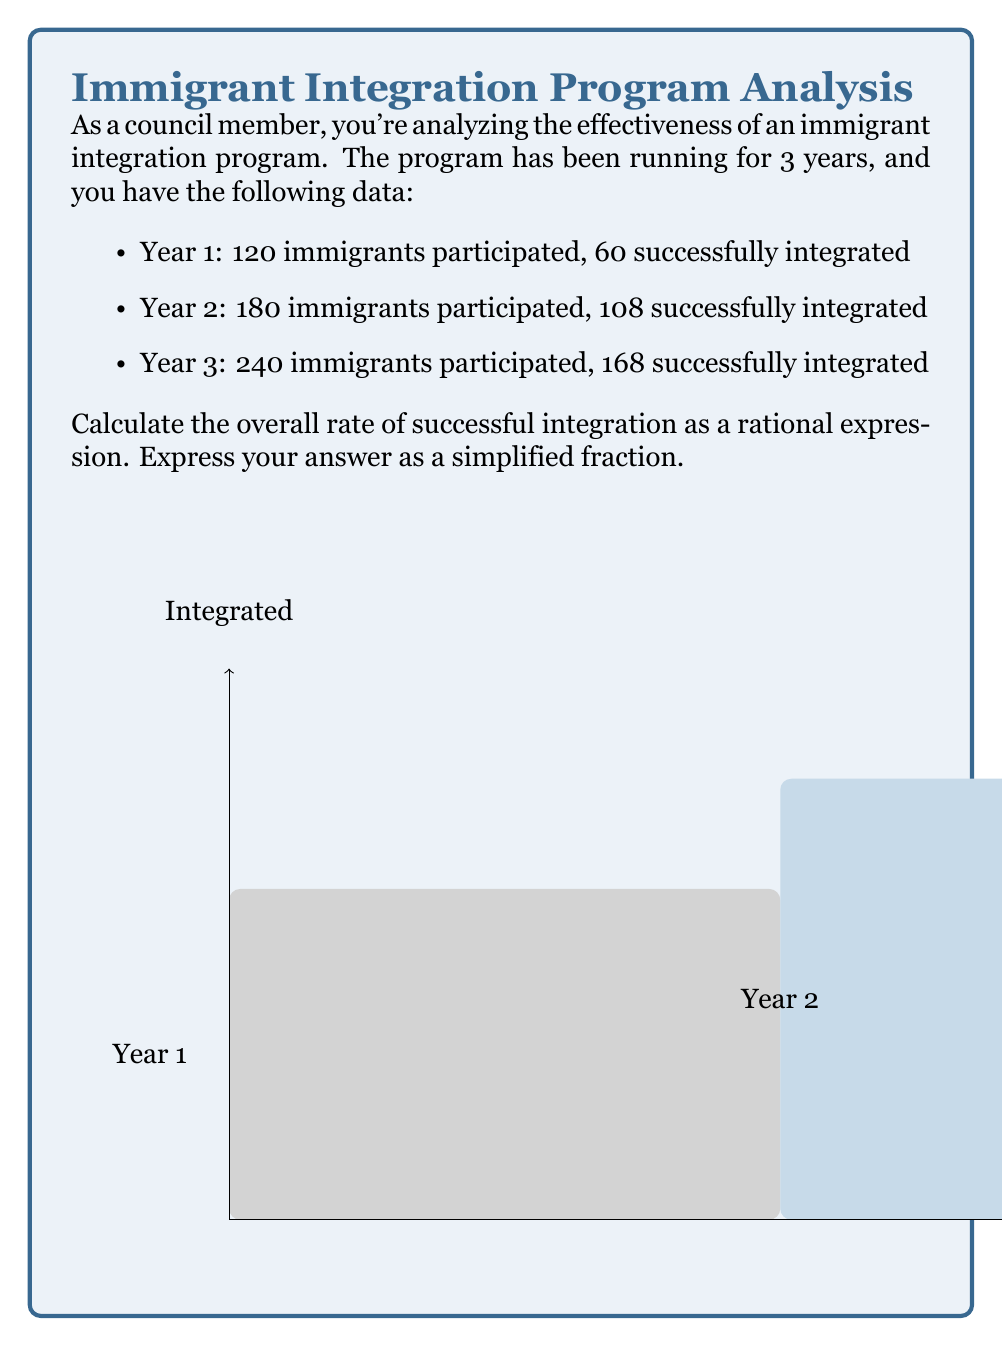Could you help me with this problem? Let's approach this step-by-step:

1) First, we need to find the total number of participants and the total number of successfully integrated immigrants over the three years.

   Total participants = 120 + 180 + 240 = 540
   Total integrated = 60 + 108 + 168 = 336

2) The rate of successful integration can be expressed as a ratio:

   $\text{Rate} = \frac{\text{Total integrated}}{\text{Total participants}}$

3) Substituting our values:

   $\text{Rate} = \frac{336}{540}$

4) To simplify this fraction, we need to find the greatest common divisor (GCD) of 336 and 540.
   
   Factors of 336: 1, 2, 3, 4, 6, 7, 8, 12, 14, 16, 21, 24, 28, 42, 48, 56, 84, 112, 168, 336
   Factors of 540: 1, 2, 3, 4, 5, 6, 9, 10, 12, 15, 18, 20, 27, 30, 36, 45, 54, 60, 90, 108, 135, 180, 270, 540

   The greatest common divisor is 12.

5) Divide both numerator and denominator by 12:

   $\frac{336}{540} = \frac{336 \div 12}{540 \div 12} = \frac{28}{45}$

Thus, the simplified rational expression for the overall rate of successful integration is $\frac{28}{45}$.
Answer: $\frac{28}{45}$ 